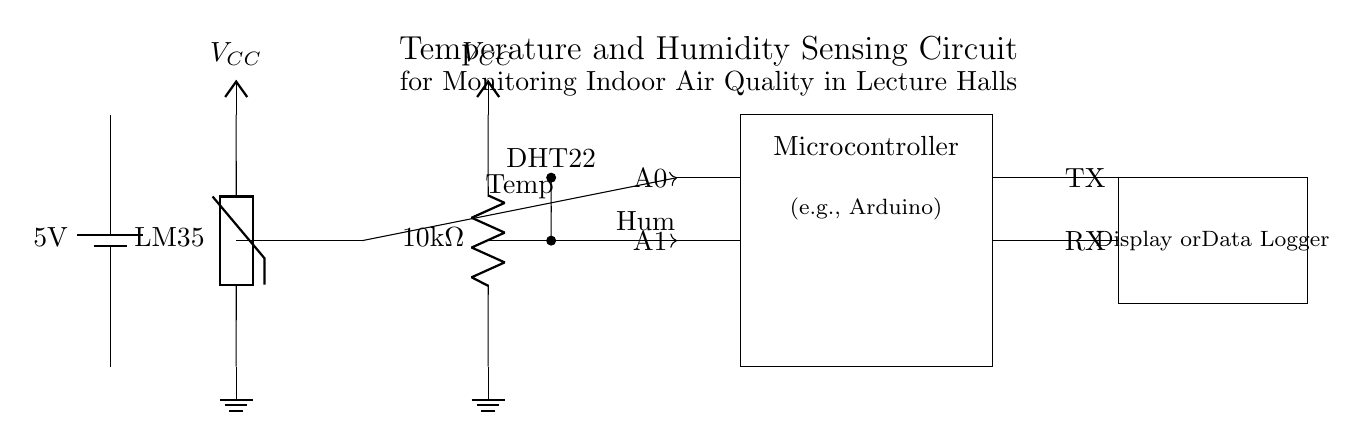What is the voltage of this circuit? The voltage is 5 volts, which is indicated by the label on the battery symbol at the top left of the circuit diagram.
Answer: 5 volts What type of humidity sensor is used in this circuit? The humidity sensor used is a DHT22, as indicated by the label next to the symbol representing it in the circuit layout.
Answer: DHT22 How many analog inputs does the microcontroller have connected to the sensors? There are two analog inputs, A0 for temperature and A1 for humidity, shown at the left side of the microcontroller component in the diagram.
Answer: Two What is the purpose of the resistor connected to the humidity sensor? The resistor is likely used to limit current to the DHT22 sensor, ensuring it operates within safe limits; this is a common practice in circuits with sensors to protect them.
Answer: Limit current What is the connection type between the sensors and the microcontroller? The connection type is one-way (unidirectional) from the sensors to the microcontroller, indicated by the arrows that show the direction of data flow; this means the sensors send data to the microcontroller.
Answer: One-way What is the function of the display or data logger in this circuit? The display or data logger is used to visualize or log the temperature and humidity data collected by the microcontroller from the sensors, allowing for monitoring and analysis.
Answer: Visualization/logging 